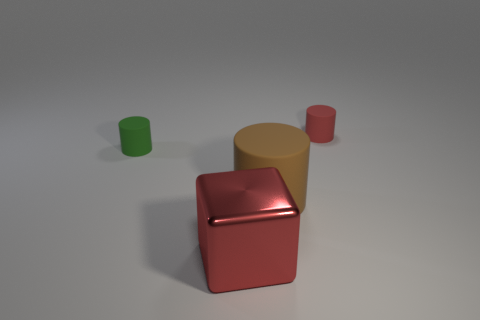There is a green object that is the same material as the small red thing; what is its size? The green object, which appears to be made of the same matte plastic as the small red object, is small in size. Both objects share similar material characteristics but come in different colors and shapes, with the green one resembling a cup, and the red, a cube. 